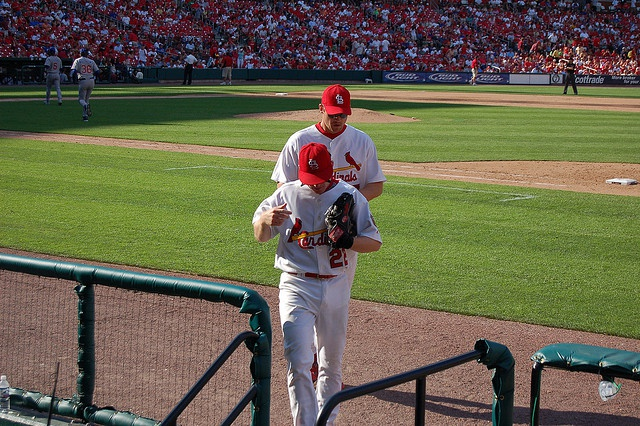Describe the objects in this image and their specific colors. I can see people in black, gray, darkgray, and white tones, people in black, gray, maroon, and white tones, baseball glove in black, maroon, gray, and darkgray tones, people in black, gray, navy, and darkblue tones, and people in black, gray, and darkblue tones in this image. 